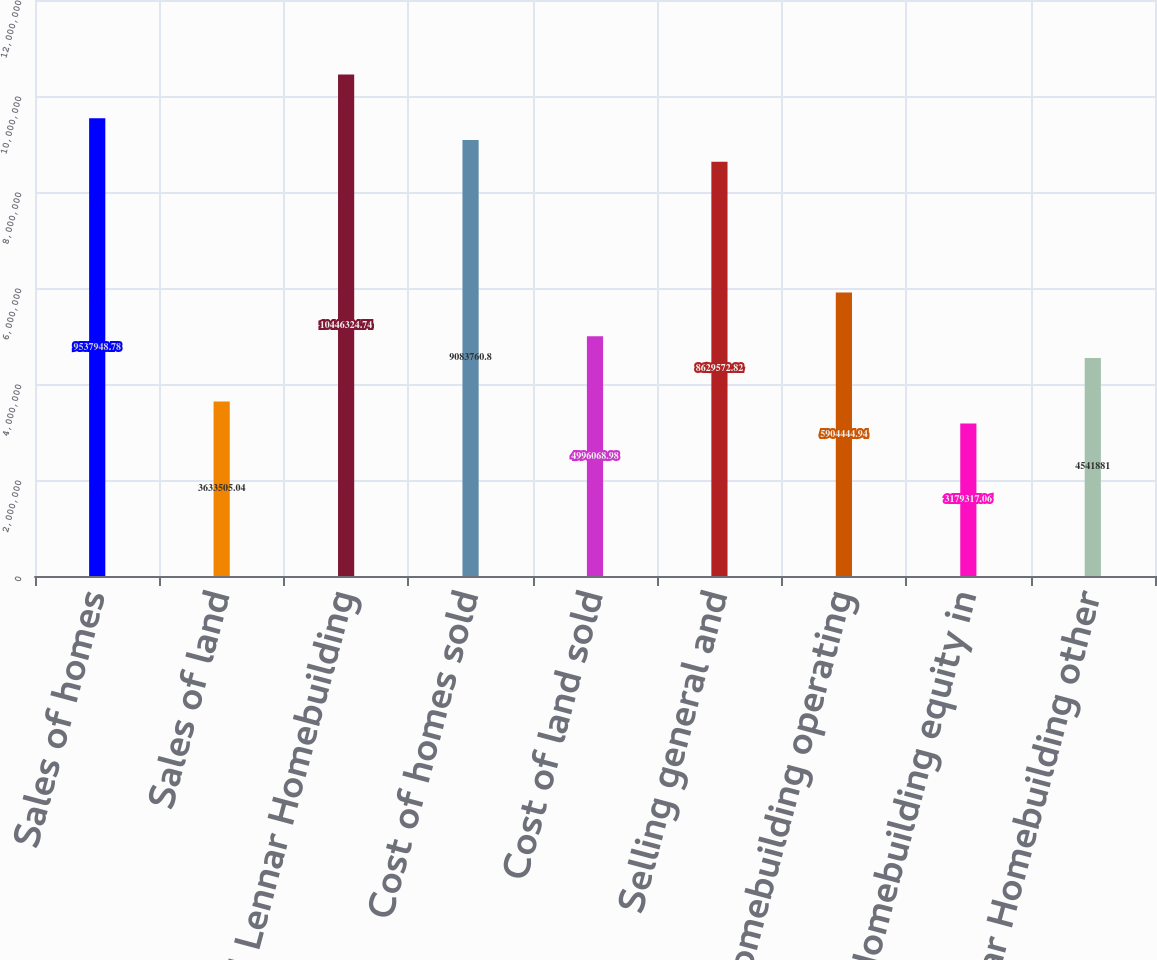Convert chart. <chart><loc_0><loc_0><loc_500><loc_500><bar_chart><fcel>Sales of homes<fcel>Sales of land<fcel>Total Lennar Homebuilding<fcel>Cost of homes sold<fcel>Cost of land sold<fcel>Selling general and<fcel>Lennar Homebuilding operating<fcel>Lennar Homebuilding equity in<fcel>Lennar Homebuilding other<nl><fcel>9.53795e+06<fcel>3.63351e+06<fcel>1.04463e+07<fcel>9.08376e+06<fcel>4.99607e+06<fcel>8.62957e+06<fcel>5.90444e+06<fcel>3.17932e+06<fcel>4.54188e+06<nl></chart> 